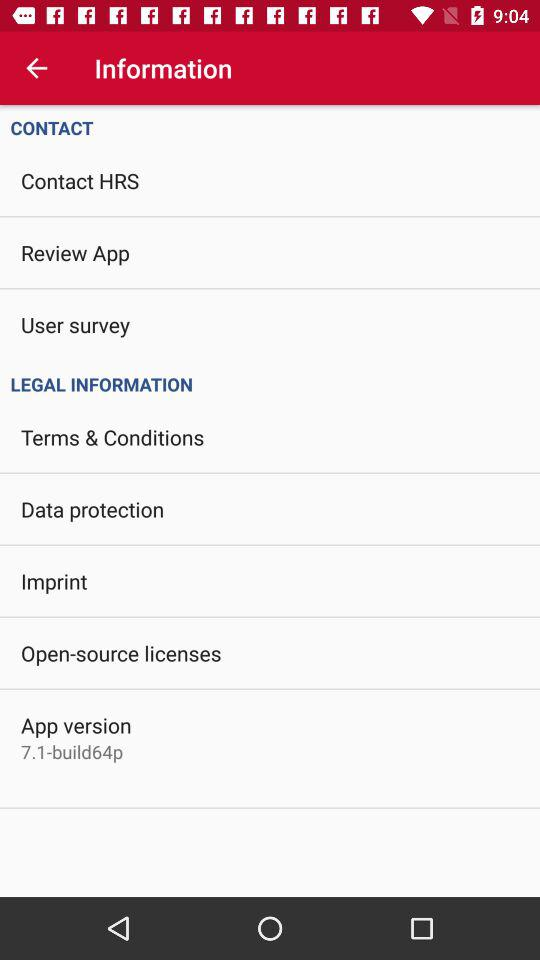Which app version is this? The app version is 7.1-build64p. 